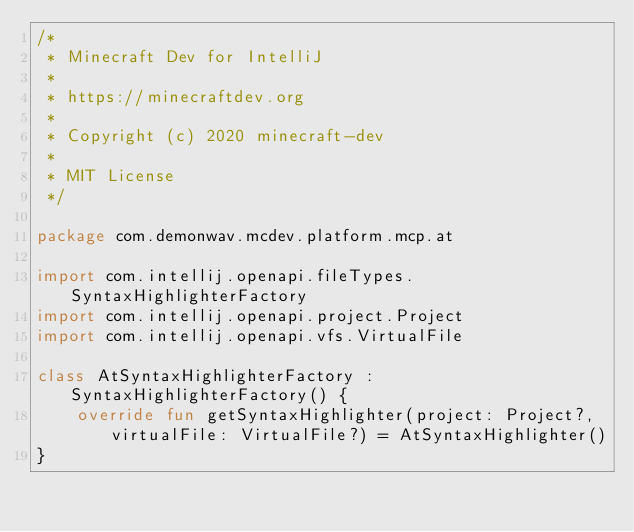<code> <loc_0><loc_0><loc_500><loc_500><_Kotlin_>/*
 * Minecraft Dev for IntelliJ
 *
 * https://minecraftdev.org
 *
 * Copyright (c) 2020 minecraft-dev
 *
 * MIT License
 */

package com.demonwav.mcdev.platform.mcp.at

import com.intellij.openapi.fileTypes.SyntaxHighlighterFactory
import com.intellij.openapi.project.Project
import com.intellij.openapi.vfs.VirtualFile

class AtSyntaxHighlighterFactory : SyntaxHighlighterFactory() {
    override fun getSyntaxHighlighter(project: Project?, virtualFile: VirtualFile?) = AtSyntaxHighlighter()
}
</code> 